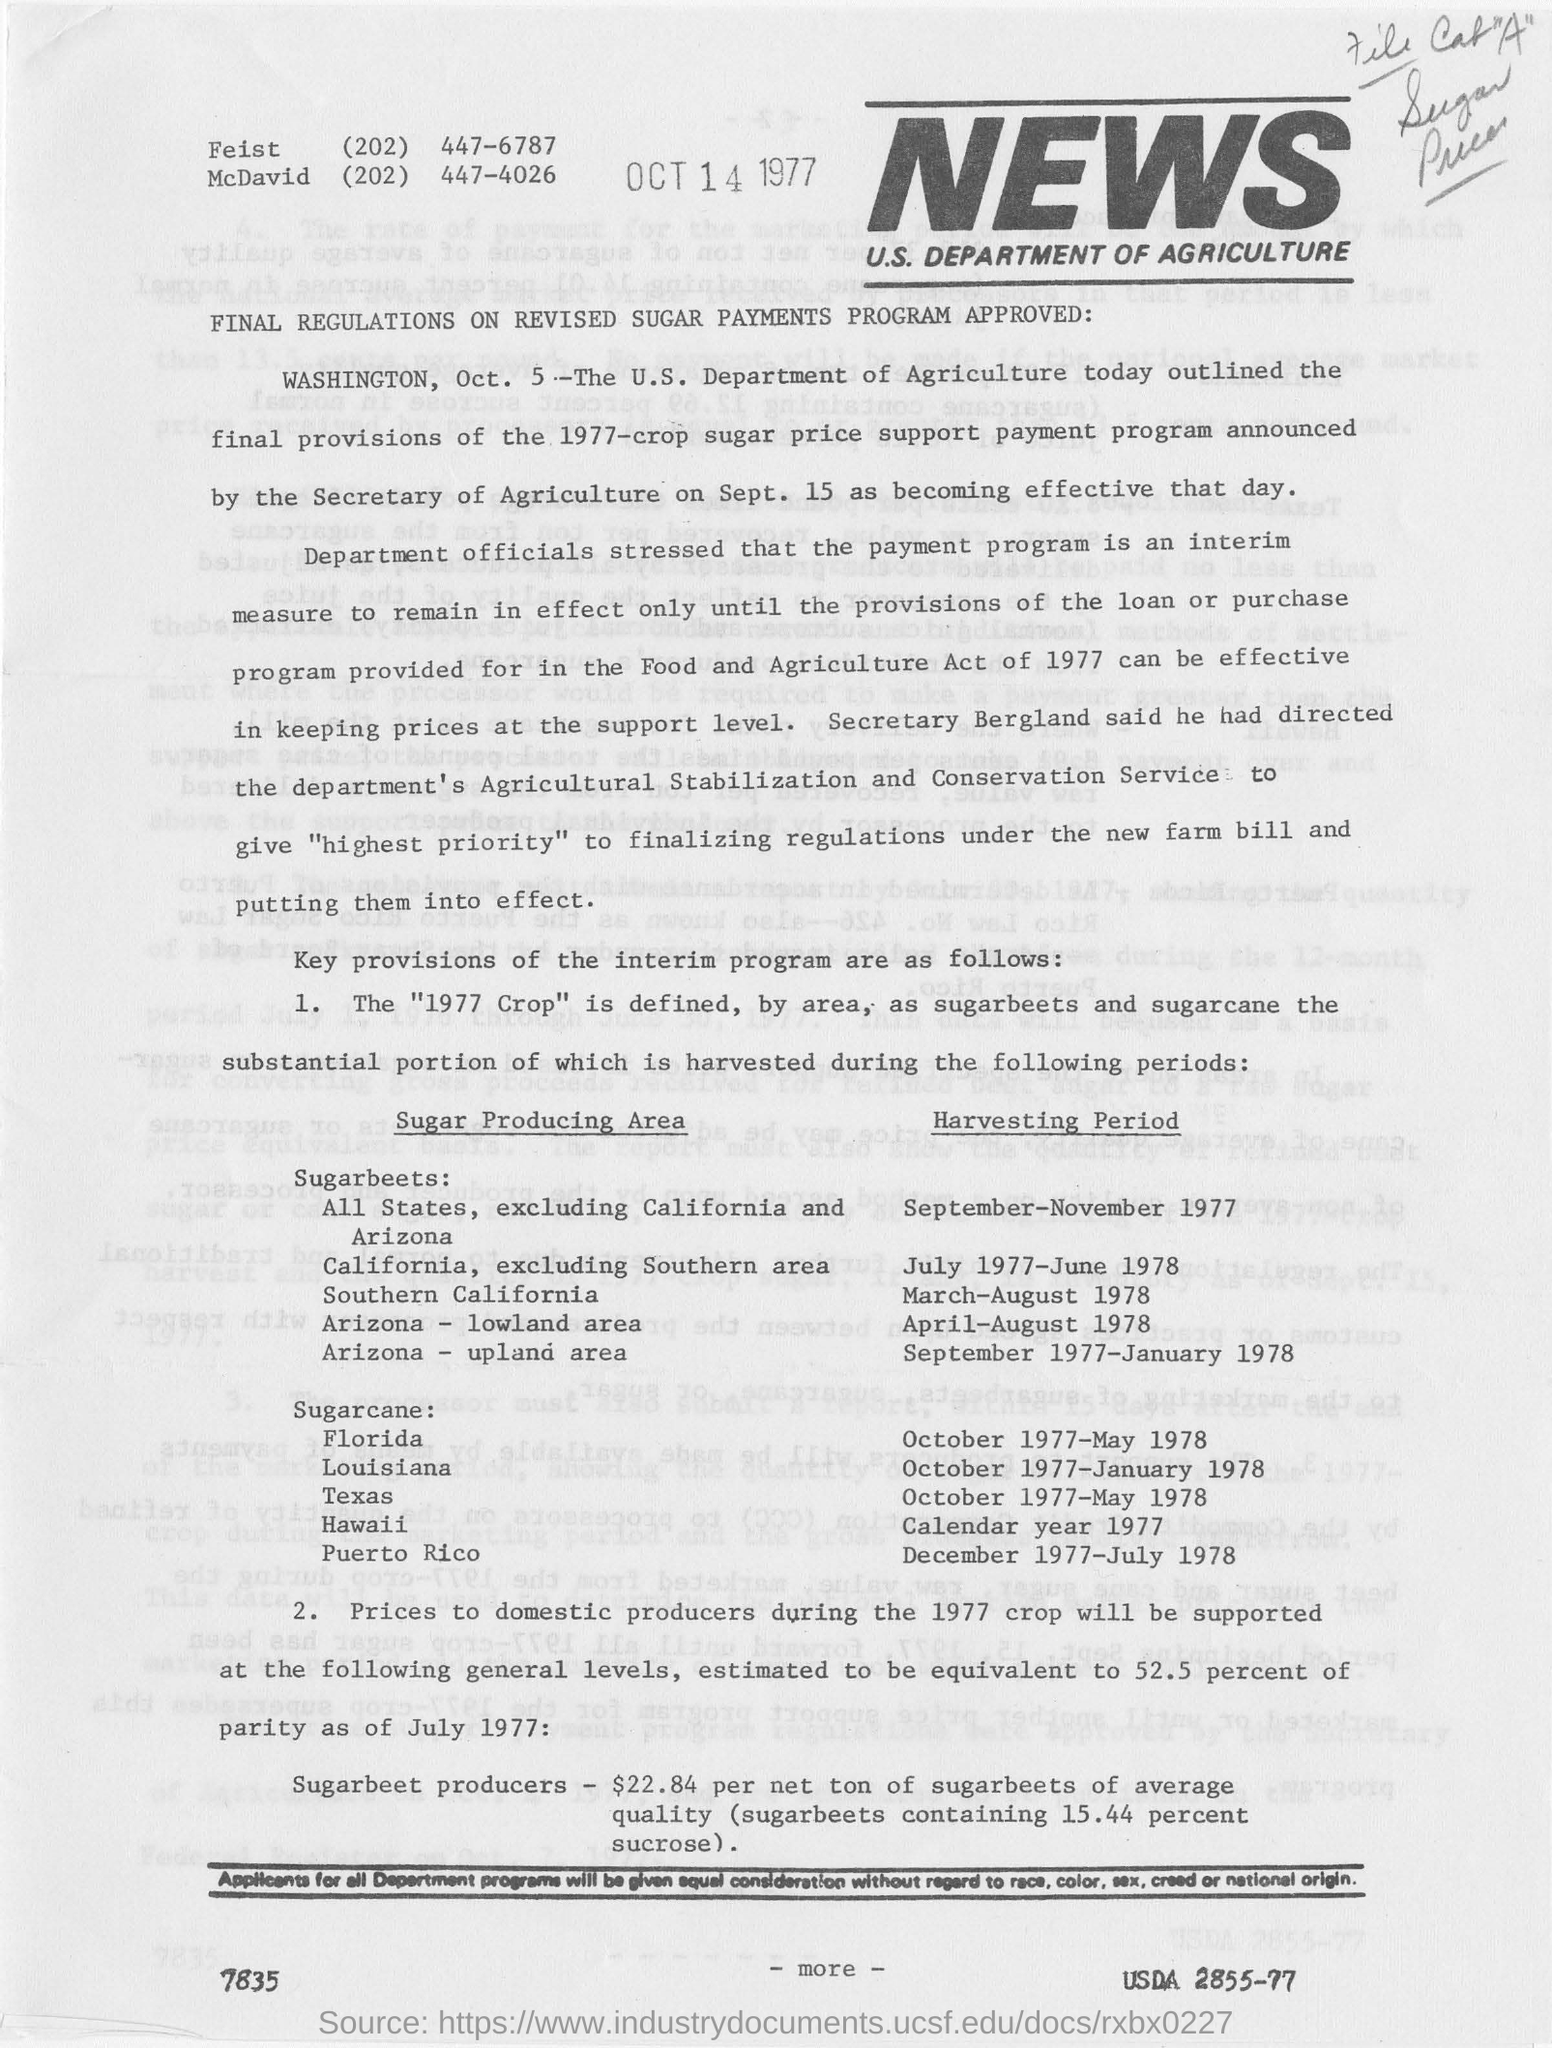Indicate a few pertinent items in this graphic. The U.S. Department of Agriculture outlined the final provisions of the 1977-crop sugar price support payment program. 